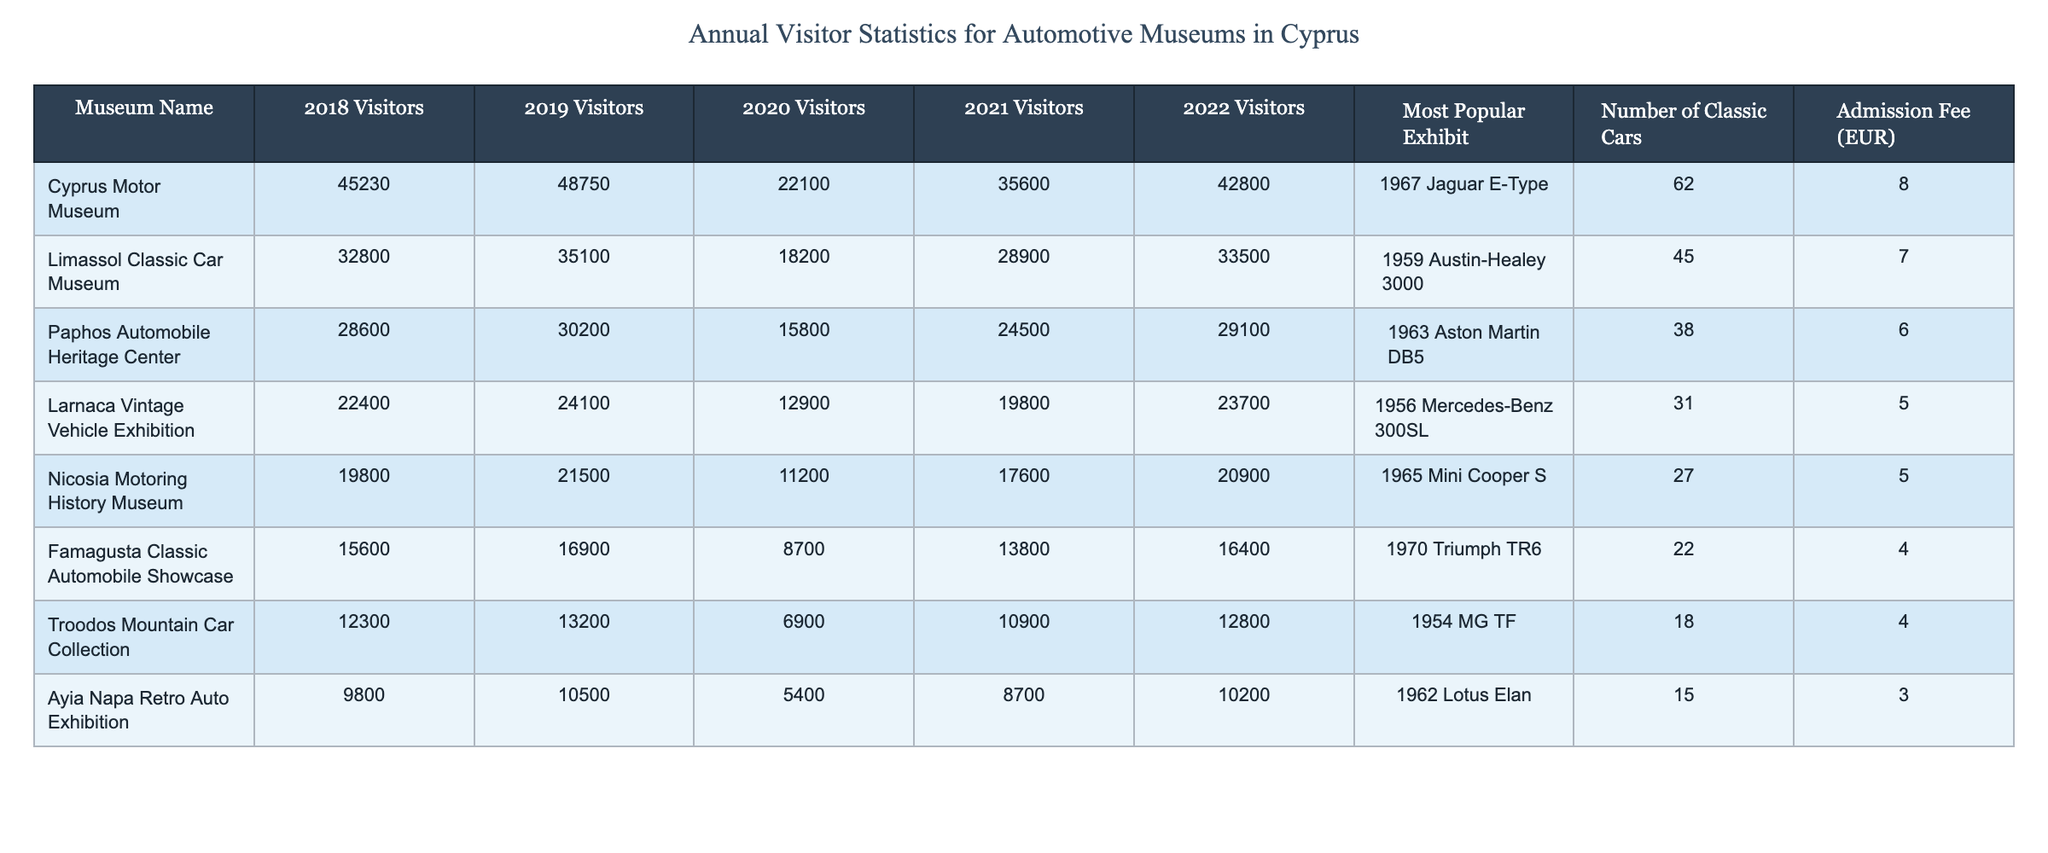What was the most popular exhibit at the Cyprus Motor Museum? The table lists the most popular exhibits for each museum, and for the Cyprus Motor Museum, it states the 1967 Jaguar E-Type as the most popular.
Answer: 1967 Jaguar E-Type Which museum had the highest number of visitors in 2022? To find which museum had the highest visitors in 2022, we can compare the visitor numbers across all museums for that year. The Cyprus Motor Museum had 42,800 visitors, which is the highest.
Answer: Cyprus Motor Museum What is the average number of visitors to the Limassol Classic Car Museum over the years listed in the table? The total number of visitors from 2018 to 2022 is 32,800 + 35,100 + 18,200 + 28,900 + 33,500 = 148,000. Dividing this by 5 (the number of years), the average is 148,000 / 5 = 29,600.
Answer: 29,600 Did the number of visitors to the Nicosia Motoring History Museum increase from 2021 to 2022? The visitor numbers for Nicosia Motoring History Museum were 17,600 in 2021 and 20,900 in 2022. Since 20,900 is greater than 17,600, the number of visitors increased.
Answer: Yes Which museum had the lowest number of classic cars on display? The table indicates the number of classic cars for each museum. The Ayia Napa Retro Auto Exhibition has 15 classic cars, which is the lowest compared to the others.
Answer: Ayia Napa Retro Auto Exhibition What was the percentage decrease in visitors to the Paphos Automobile Heritage Center from 2019 to 2020? The number of visitors in 2019 was 30,200 and in 2020 it was 15,800. To find the decrease, we subtract the 2020 visitors from the 2019 visitors (30,200 - 15,800 = 14,400). The percentage decrease is (14,400 / 30,200) * 100 = approximately 47.8%.
Answer: 47.8% Which museum had consistently increasing visitor numbers from 2018 to 2022? We can look at the visitor numbers for each museum from 2018 to 2022 to determine if any had consistently increasing numbers. Upon review, no museum had a consistent increase every year; hence the answer is none.
Answer: None What is the total number of visitors for all museums in 2021? To find the total visitors for 2021, we sum the visitors: 35,600 + 28,900 + 24,500 + 19,800 + 17,600 + 13,800 + 10,900 + 8,700 = 139,800.
Answer: 139,800 Which museum has the most classic cars on display? The table shows that the Cyprus Motor Museum has 62 classic cars, which is the highest number among all listed museums.
Answer: Cyprus Motor Museum Is the admission fee for the Famagusta Classic Automobile Showcase higher than that of the Larnaca Vintage Vehicle Exhibition? The admission fee for Famagusta Classic Automobile Showcase is 4 EUR while Larnaca Vintage Vehicle Exhibition is 5 EUR. Since 4 is not greater than 5, the answer is no.
Answer: No How many more visitors did the Troodos Mountain Car Collection have in 2022 compared to 2021? Troodos Mountain Car Collection had 12,800 visitors in 2022 and 10,900 in 2021. The difference in visitors is 12,800 - 10,900 = 1,900.
Answer: 1,900 